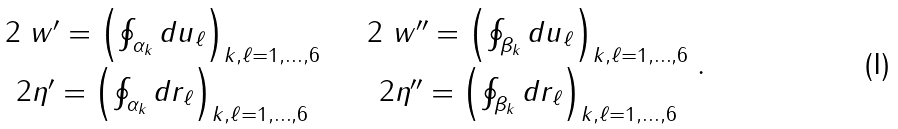Convert formula to latex. <formula><loc_0><loc_0><loc_500><loc_500>\begin{array} { c c } 2 \ w ^ { \prime } = \left ( \oint _ { \alpha _ { k } } d u _ { \ell } \right ) _ { k , \ell = 1 , \dots , 6 } & \quad 2 \ w ^ { \prime \prime } = \left ( \oint _ { \beta _ { k } } d u _ { \ell } \right ) _ { k , \ell = 1 , \dots , 6 } \\ 2 \eta ^ { \prime } = \left ( \oint _ { \alpha _ { k } } d r _ { \ell } \right ) _ { k , \ell = 1 , \dots , 6 } & \quad 2 \eta ^ { \prime \prime } = \left ( \oint _ { \beta _ { k } } d r _ { \ell } \right ) _ { k , \ell = 1 , \dots , 6 } \end{array} .</formula> 